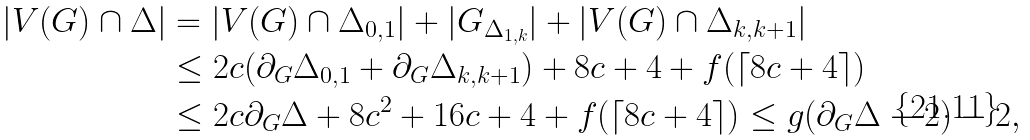<formula> <loc_0><loc_0><loc_500><loc_500>| V ( G ) \cap \Delta | & = | V ( G ) \cap \Delta _ { 0 , 1 } | + | G _ { \Delta _ { 1 , k } } | + | V ( G ) \cap \Delta _ { k , k + 1 } | \\ & \leq 2 c ( \partial _ { G } \Delta _ { 0 , 1 } + \partial _ { G } \Delta _ { k , k + 1 } ) + 8 c + 4 + f ( \lceil 8 c + 4 \rceil ) \\ & \leq 2 c \partial _ { G } \Delta + 8 c ^ { 2 } + 1 6 c + 4 + f ( \lceil 8 c + 4 \rceil ) \leq g ( \partial _ { G } \Delta - 2 ) - 2 ,</formula> 